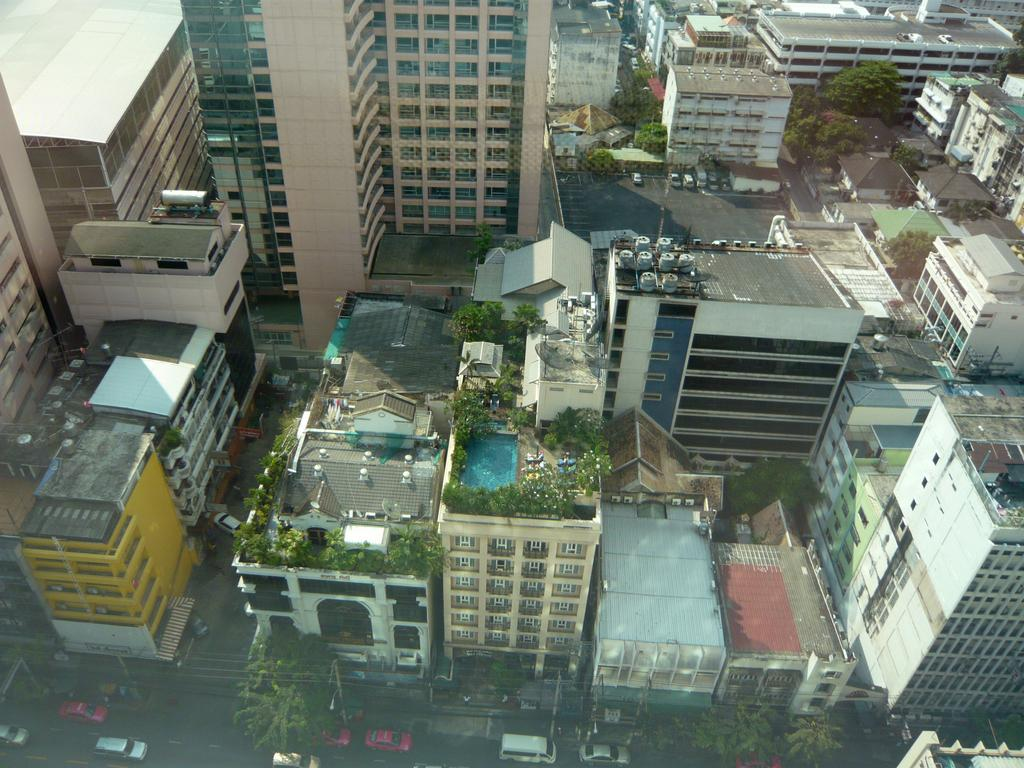What type of structures can be seen in the image? There are buildings in the image. What other natural or man-made elements are present in the image? There are trees and vehicles on the road in the image. Can you describe a specific feature of one of the buildings? There is a swimming pool on a building in the image. How many boys are playing peacefully in the grass in the image? There are no boys or grass present in the image. 